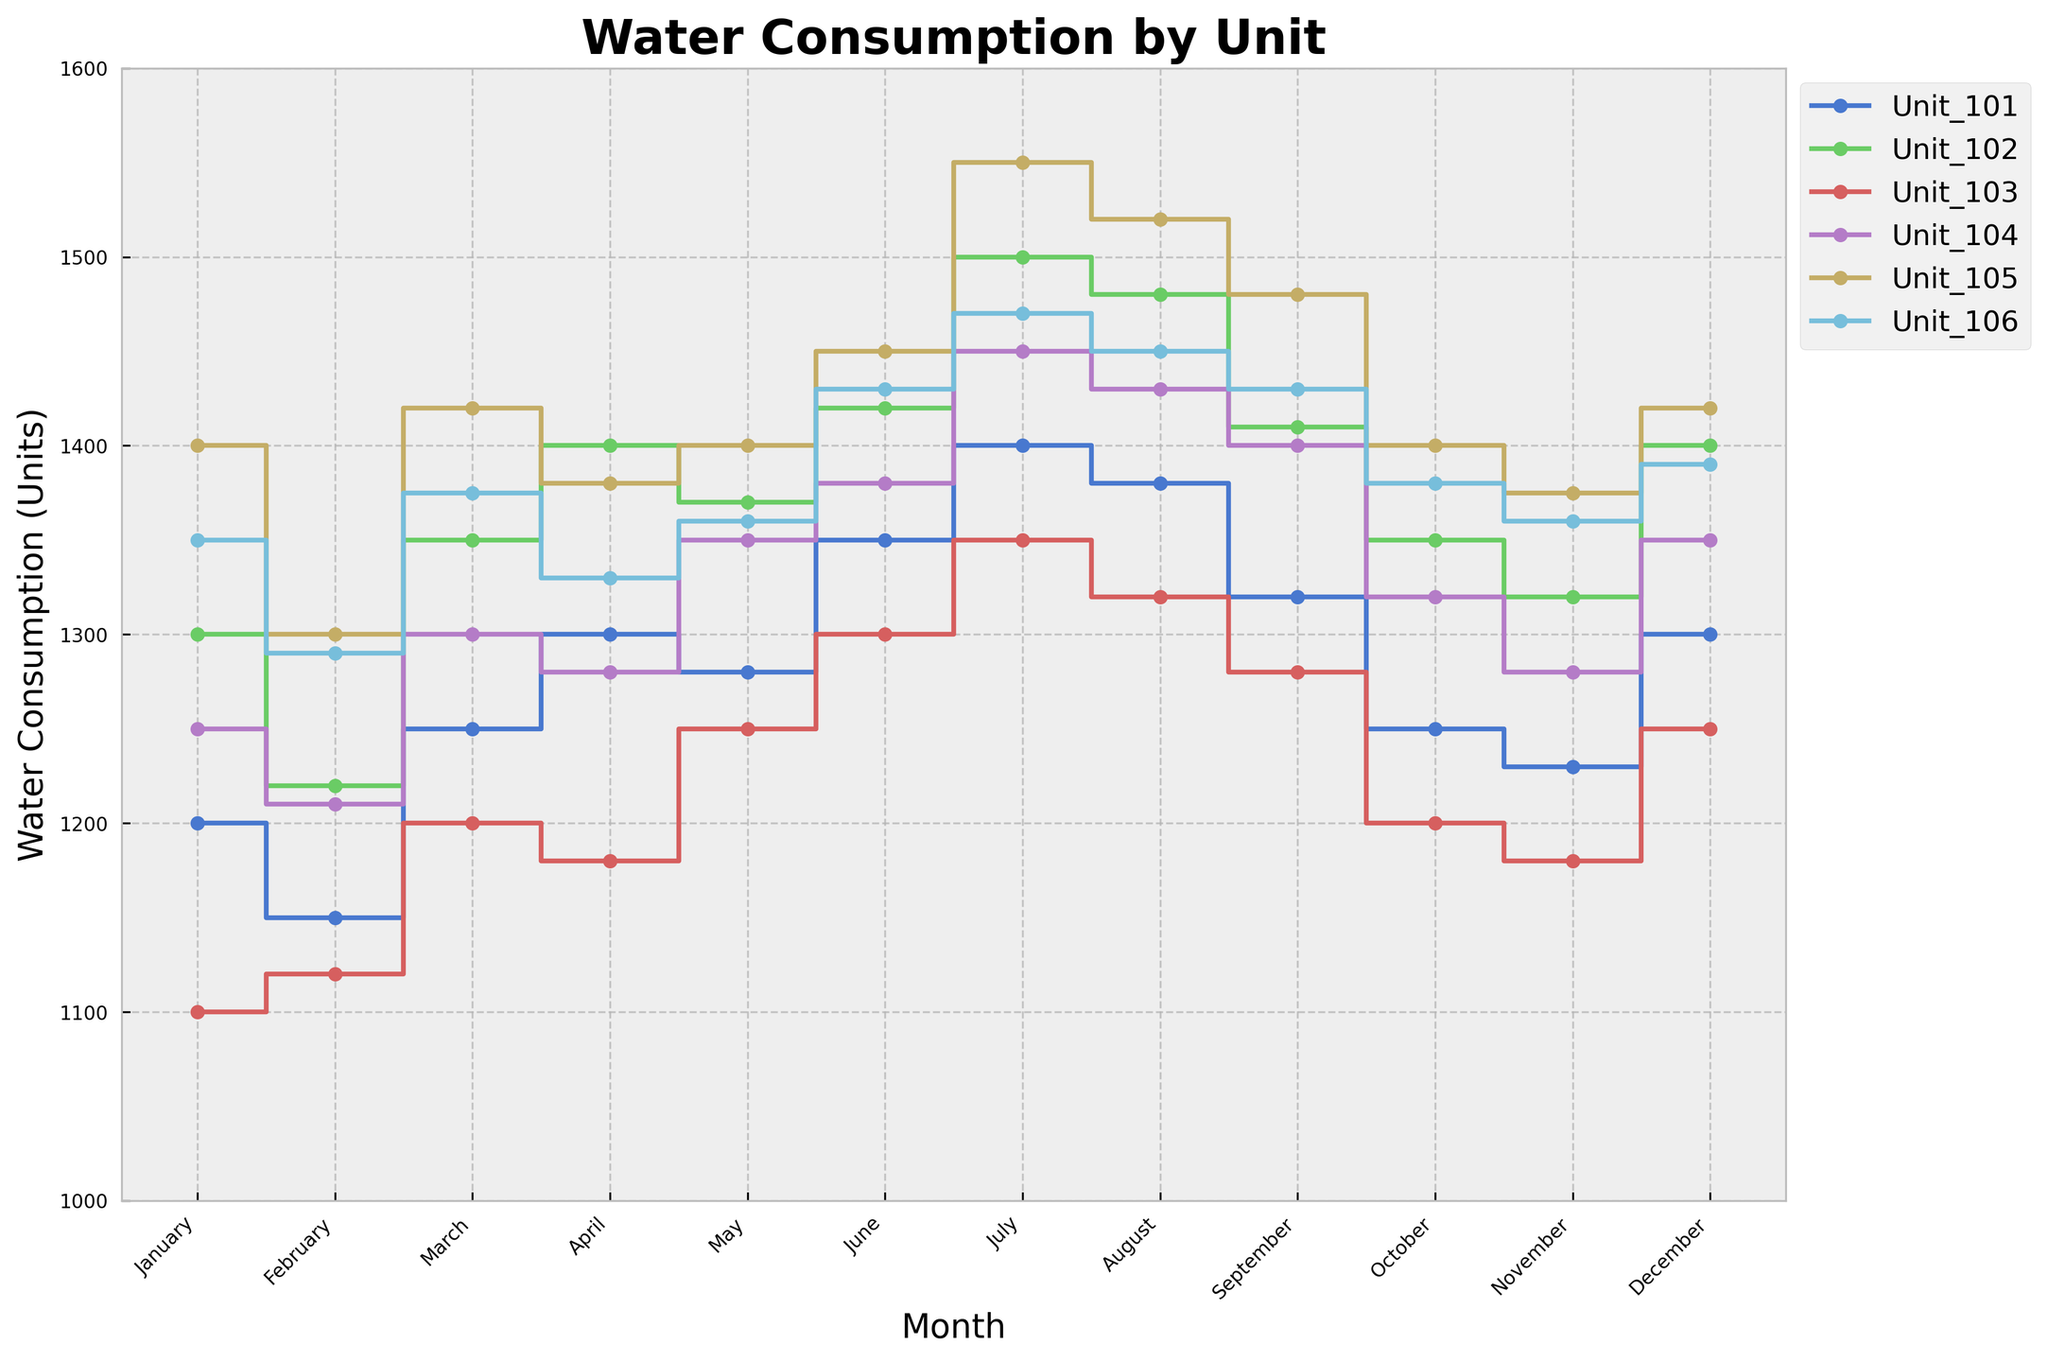What is the title of the plot? The plot's title is usually displayed at the top of the figure, which provides a brief description of the visualized data.
Answer: Water Consumption by Unit Which unit had the highest water consumption in July? Look at the stair plot line corresponding to each unit and find the maximum peak in the month of July, which is usually marked as either the highest point or with the highest corresponding value.
Answer: Unit_105 How does the water consumption of Unit_103 in March compare to January? Find the water consumption values for Unit_103 in both March and January from the stair plot and compare the two values.
Answer: March is higher What is the average water consumption of Unit_104 for the entire year? Add the monthly water consumption values of Unit_104 throughout the year and divide by 12 to get the average.
Answer: (1250+1210+1300+1280+1350+1380+1450+1430+1400+1320+1280+1350)/12 = 1325 Which month saw the lowest water consumption for Unit_106? Identify the minimum point on the stair plot line corresponding to Unit_106 and note the respective month.
Answer: February Between which two months did Unit_102 see the highest increase in water consumption? Examine the differences in water consumption values between consecutive months for Unit_102 and identify the two months with the highest positive change.
Answer: June to July Is there a month where all units have increased water consumption compared to the previous month? Compare each unit's water consumption of each month to the previous one and check if all units show an increase in any particular month.
Answer: March What is the water consumption range for Unit_101 throughout the year? Identify the minimum and maximum water consumption values for Unit_101 from the stair plot and calculate the range (max-min).
Answer: 1400-1150 = 250 Which unit had the most stable water consumption, based on the least fluctuation throughout the year? Calculate the standard deviation or range of values for each unit and identify the unit with the lowest fluctuation.
Answer: Unit_103 During which month did Unit_105 experience its peak water consumption? Identify the month where Unit_105’s stair plot reaches its highest point.
Answer: July 